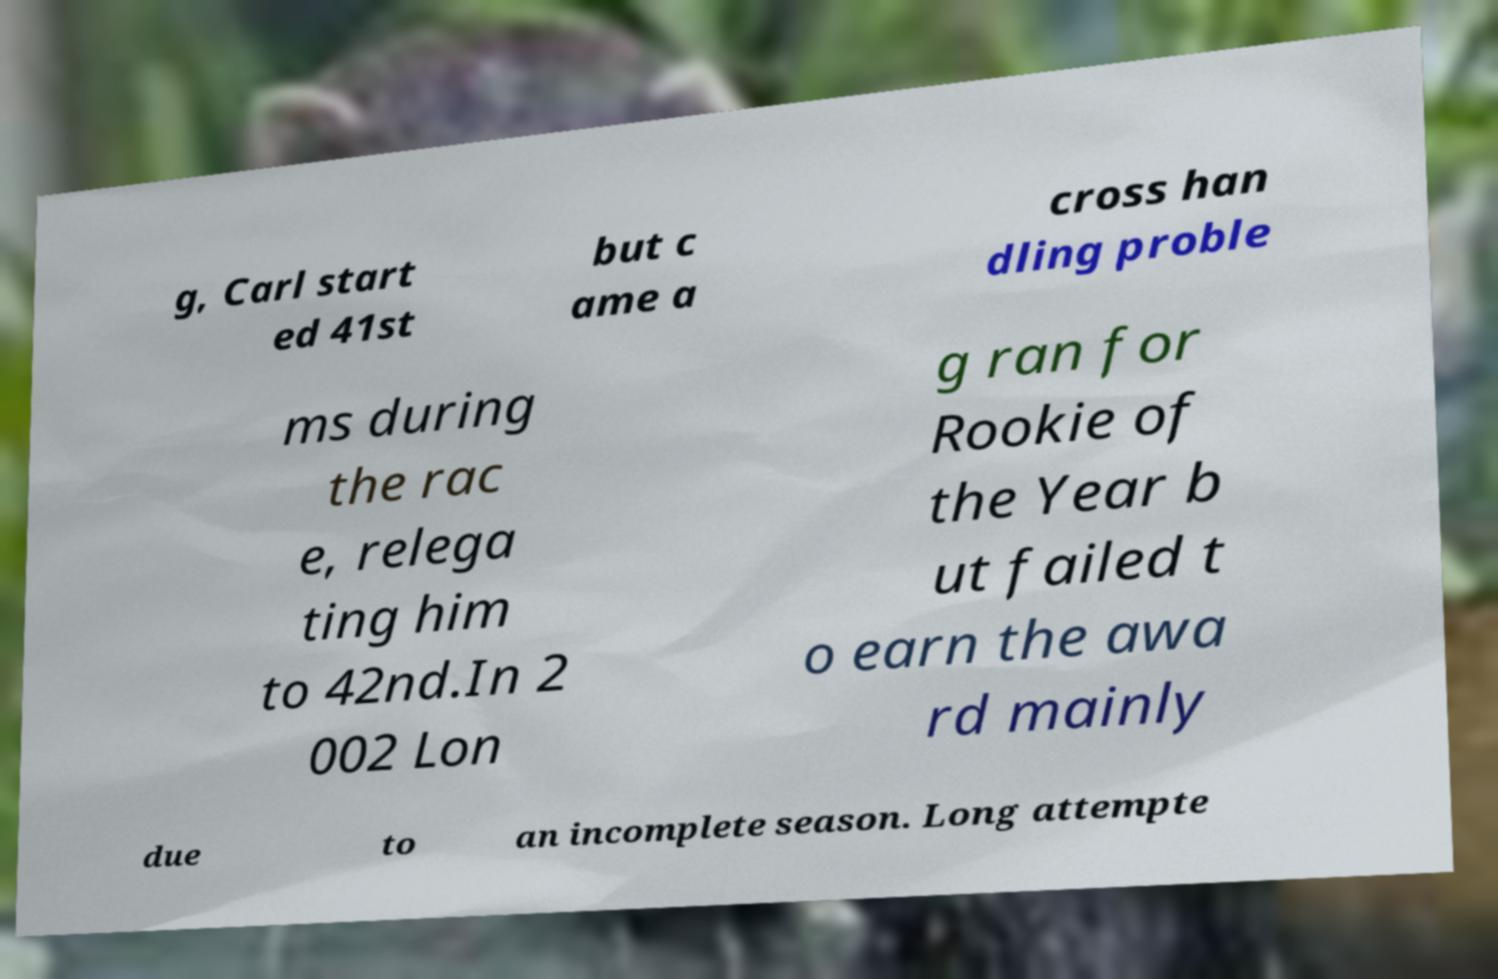Could you extract and type out the text from this image? g, Carl start ed 41st but c ame a cross han dling proble ms during the rac e, relega ting him to 42nd.In 2 002 Lon g ran for Rookie of the Year b ut failed t o earn the awa rd mainly due to an incomplete season. Long attempte 